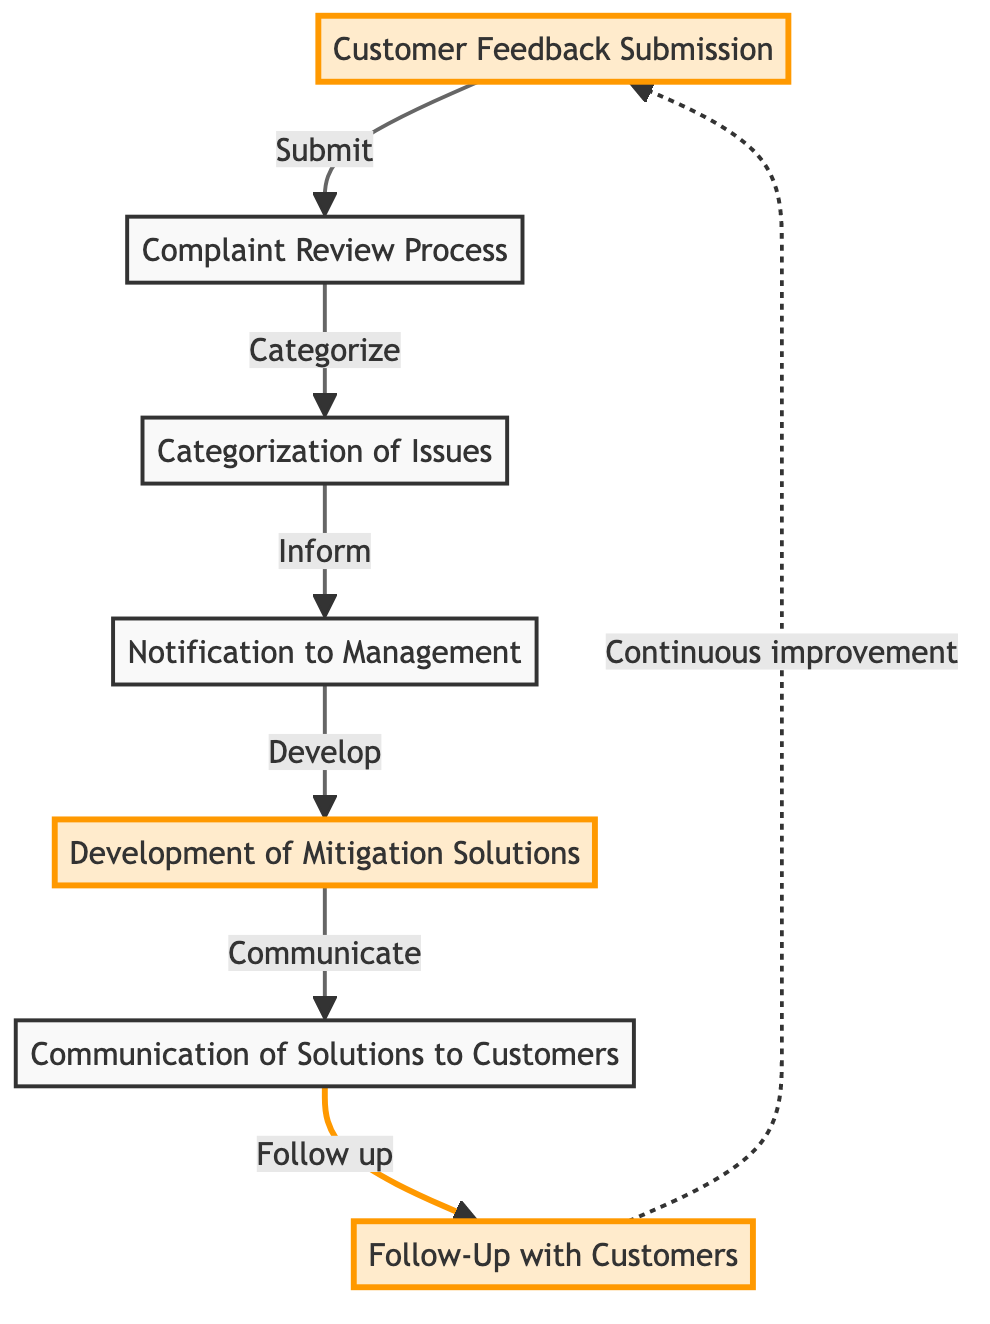What is the first step in the flow of complaints? The first step is the "Customer Feedback Submission," where customers submit their feedback via various channels.
Answer: Customer Feedback Submission How many nodes are in this flowchart? The flowchart contains 7 nodes representing different stages of the complaint process, from submission to follow-up.
Answer: 7 What follows the complaint review process? After the "Complaint Review Process," the next step is the "Categorization of Issues," where the staff categorizes the feedback into specific types.
Answer: Categorization of Issues What does the business do after being notified about issues? Following the "Notification to Management," the business develops solutions in the "Development of Mitigation Solutions" stage to address the complaints.
Answer: Development of Mitigation Solutions What action involves communicating with customers? The action that involves communicating with customers is "Communication of Solutions to Customers," where they inform customers about actions taken.
Answer: Communication of Solutions to Customers What is the purpose of the follow-up with customers? The purpose of the "Follow-Up with Customers" is to assess customer satisfaction with the solutions implemented in response to their feedback.
Answer: Assess satisfaction What links "Development of Mitigation Solutions" to "Customer Feedback Submission"? The flow from "Development of Mitigation Solutions" creates a loop back to "Customer Feedback Submission," indicating continuous improvement based on customer feedback.
Answer: Continuous improvement Which nodes are highlighted in the diagram? The highlighted nodes in the diagram are "Customer Feedback Submission," "Development of Mitigation Solutions," and "Follow-Up with Customers," indicating their importance in the process.
Answer: Customer Feedback Submission, Development of Mitigation Solutions, Follow-Up with Customers What type of issues are categorized after the complaint review? After the complaint review, issues are categorized into various types, such as accessibility issues and service complaints, depending on the feedback received.
Answer: Accessibility issues, service complaints 